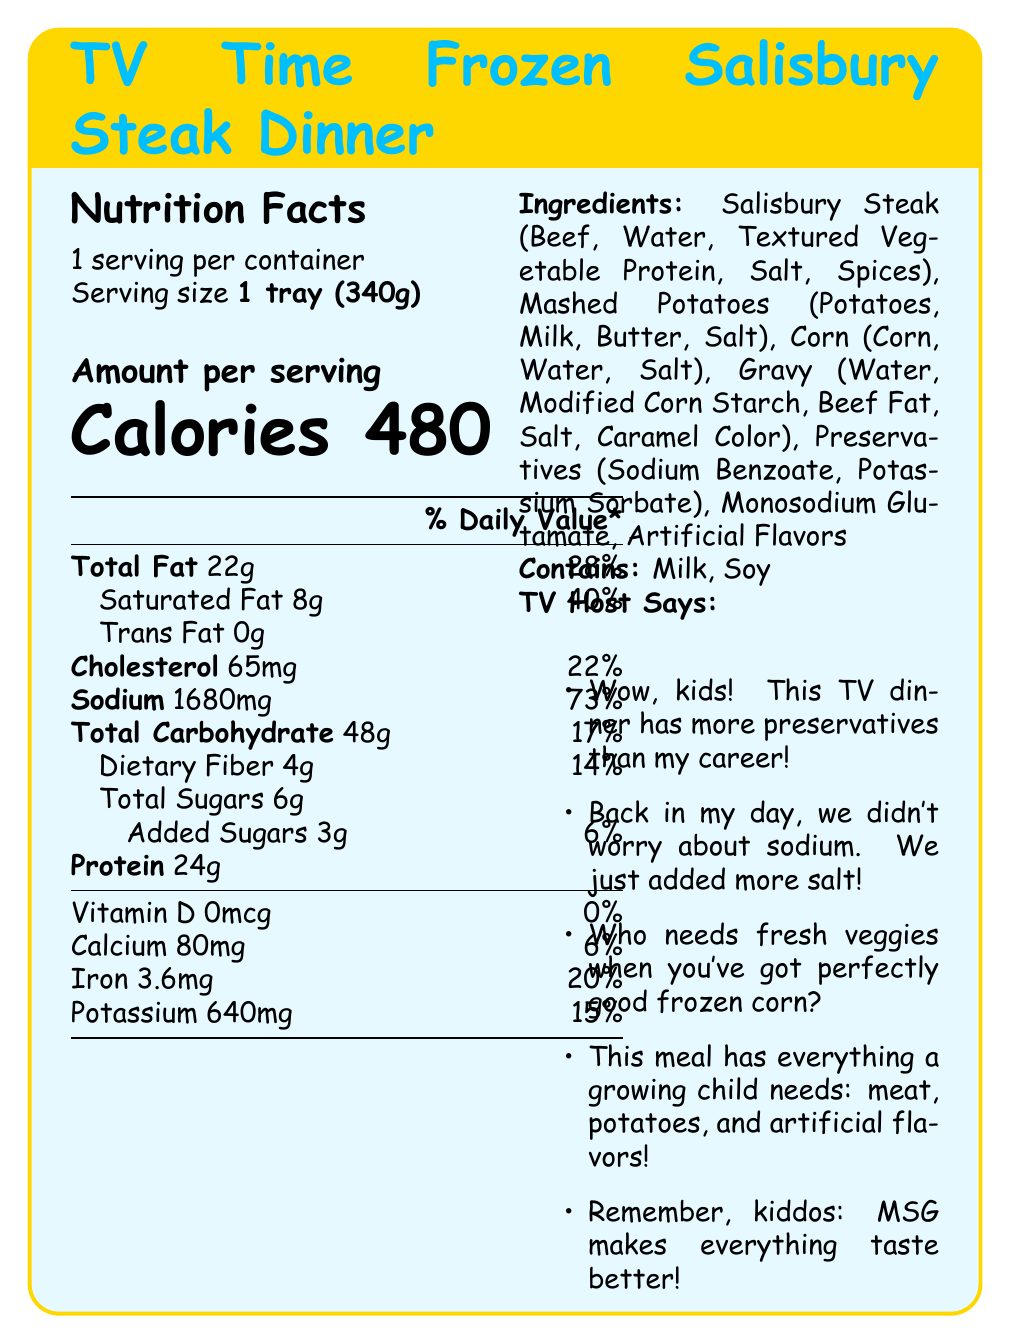what is the serving size for the TV Time Frozen Salisbury Steak Dinner? The serving size is explicitly mentioned as "1 tray (340g)" in the document.
Answer: 1 tray (340g) how many calories are in one serving of the TV dinner? The document states that one serving contains 480 calories.
Answer: 480 Calories how much sodium does one serving contain? According to the Nutrition Facts, sodium content per serving is 1680mg.
Answer: 1680mg what percentage of the daily value for saturated fat does one serving provide? The document indicates that one serving of the TV dinner provides 40% of the daily value for saturated fat.
Answer: 40% what ingredients are used in the Salisbury Steak? The ingredients listed for the Salisbury Steak include Beef, Water, Textured Vegetable Protein, Salt, and Spices.
Answer: Beef, Water, Textured Vegetable Protein, Salt, Spices which of the following contains preservatives? A. Mashed Potatoes B. Corn C. Gravy D. Salisbury Steak The ingredients list shows that the gravy contains preservatives like Sodium Benzoate and Potassium Sorbate.
Answer: C. Gravy what is the total amount of dietary fiber in one serving? A. 2g B. 4g C. 6g D. 8g The Nutrition Facts section specifies that one serving contains 4g of dietary fiber.
Answer: B. 4g how many grams of protein are in one serving of the TV dinner? A. 22g B. 24g C. 26g D. 28g The document states that the TV dinner contains 24g of protein per serving.
Answer: B. 24g does this TV dinner contain any artificial flavors? The ingredients list includes artificial flavors.
Answer: Yes does the TV dinner provide any Vitamin D? The Nutrition Facts specify that the amount of Vitamin D is 0mcg, which means it does not provide any Vitamin D.
Answer: No summarize the main idea of the document. The document covers detailed Nutrition Facts, lists ingredients, and features playful comments by a TV host, centering on the convenience and flavor additives of the TV dinner.
Answer: The document provides nutrition and ingredient information about the TV Time Frozen Salisbury Steak Dinner, highlighting its high sodium content and including comments from a former 80's kids' show TV host. how many daily servings are recommended on the label? The document provides the serving size for one tray but doesn't specify any recommended daily servings.
Answer: Not enough information 